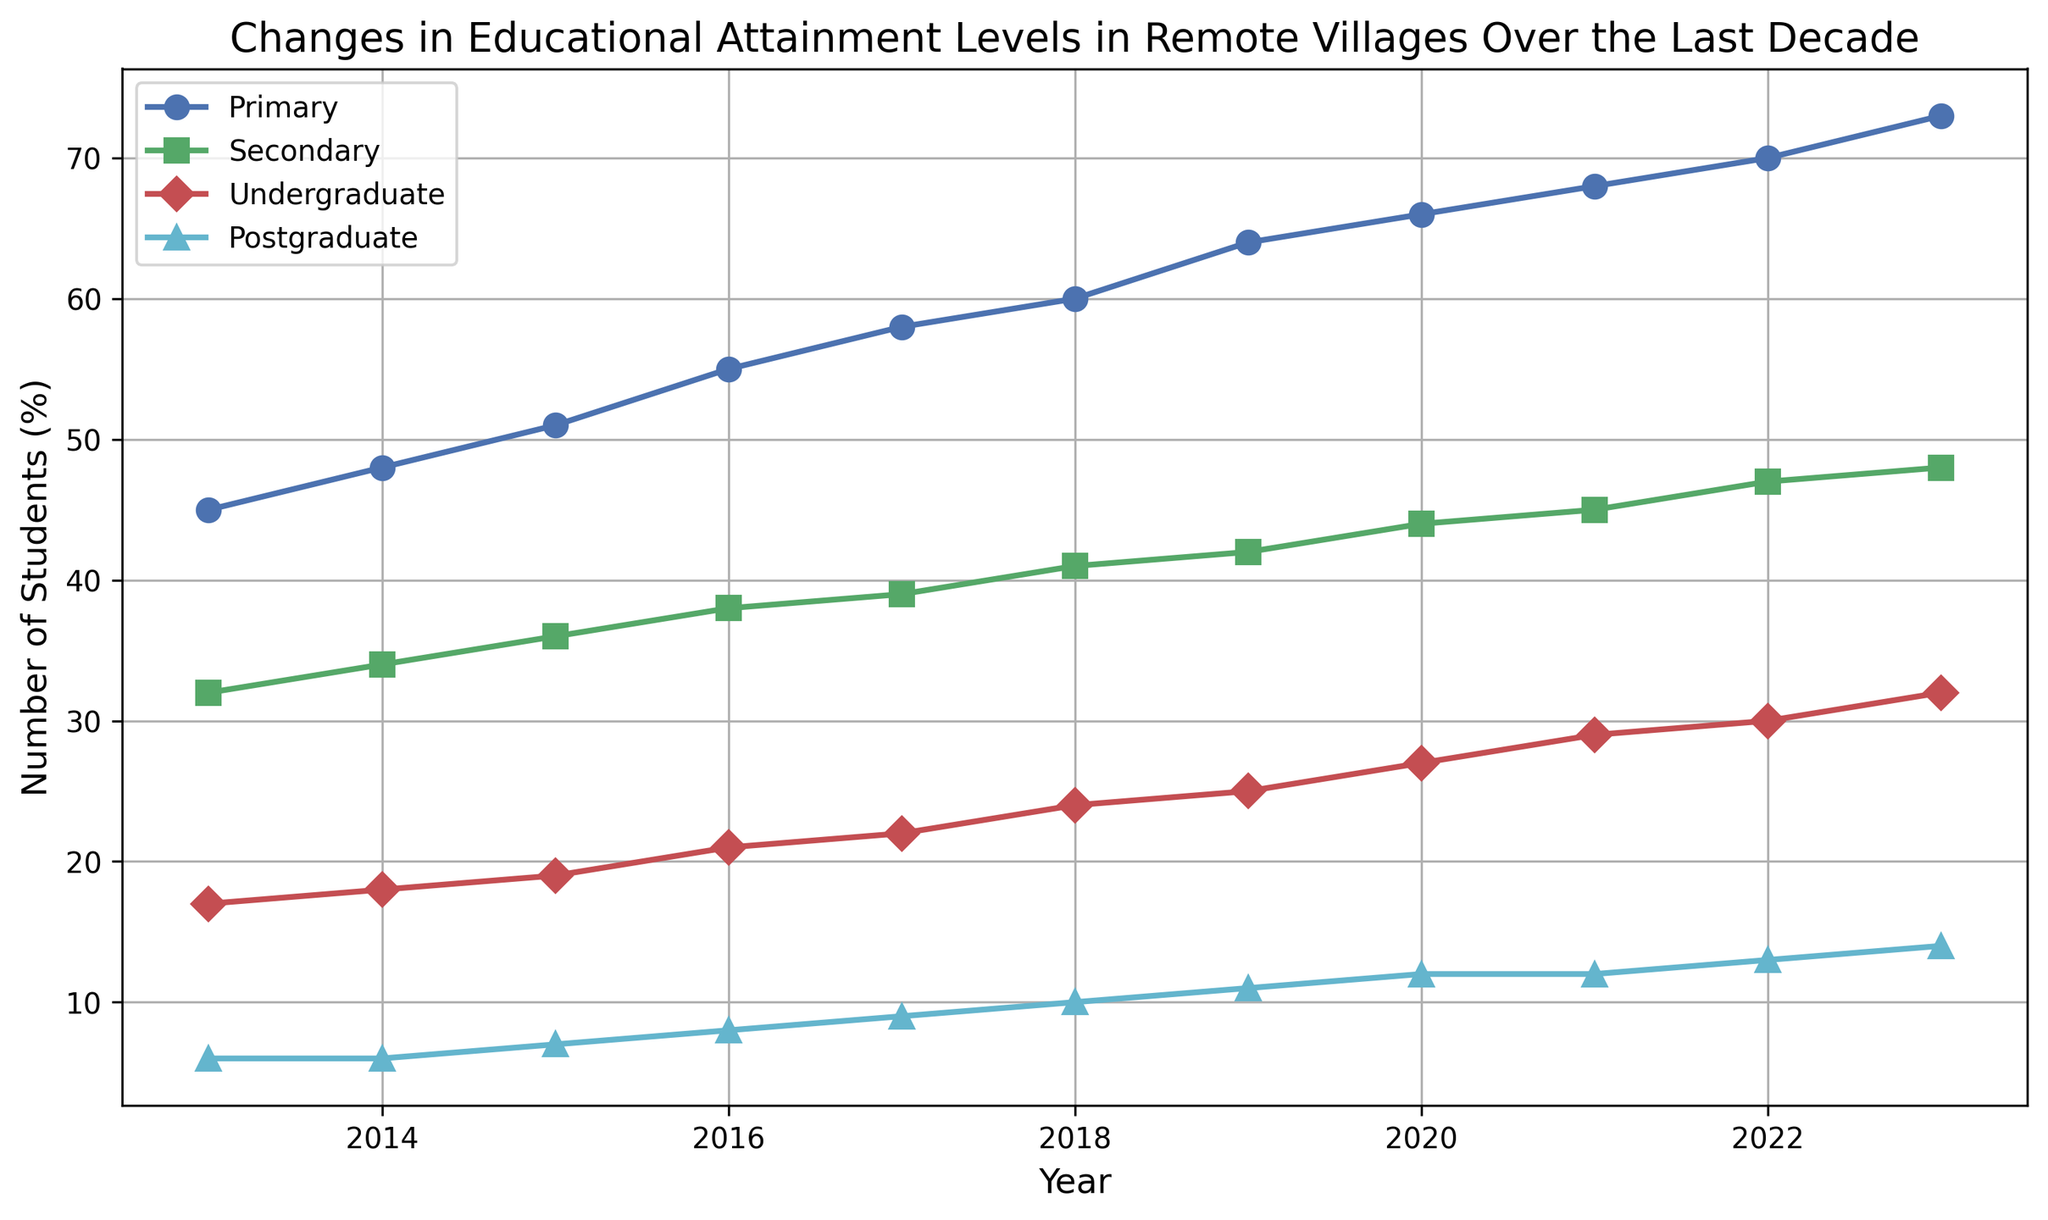Which educational level had the highest percentage of students in 2023? Observe the endpoints of the lines for 2023 on the plot. The "Primary" line ends the highest, indicating the highest percentage of students in 2023.
Answer: Primary Between which two consecutive years did the percentage of undergraduate students increase the most? Look at the year-to-year changes in the "Undergraduate" line. The largest vertical jump is between 2019 and 2020 (from 25% to 27%).
Answer: 2019-2020 By how much did the percentage of students with secondary education change from 2013 to 2023? Find the values for "Secondary" education in 2013 and 2023, then compute the difference (48% in 2023 - 32% in 2013).
Answer: 16% Which educational level showed consistent growth every year without any decline? Examine each line for consistent upward trends without any dips. The "Primary" and "Secondary" lines both show consistent growth.
Answer: Primary and Secondary In 2015, how many more students (percentage-wise) had primary education compared to postgraduate education? Subtract the percentage of postgraduate students from primary students in 2015 (51% - 7%).
Answer: 44% Which two educational levels had equal percentages of students in 2014 and what was that percentage? Look at the lines closely for 2014; the "Postgraduate" has 6%, and "Postgraduate" also has 6%.
Answer: Postgraduate and Postgraduate, 6% What is the percentage difference between undergraduate and postgraduate students in 2023? Subtract the percentage of postgraduate students from undergraduate students in 2023 (32% - 14%).
Answer: 18% In which year did the percentage of students with primary education first reach 60%? Follow the "Primary" line to see when it first crosses the 60% mark, which is in 2018.
Answer: 2018 